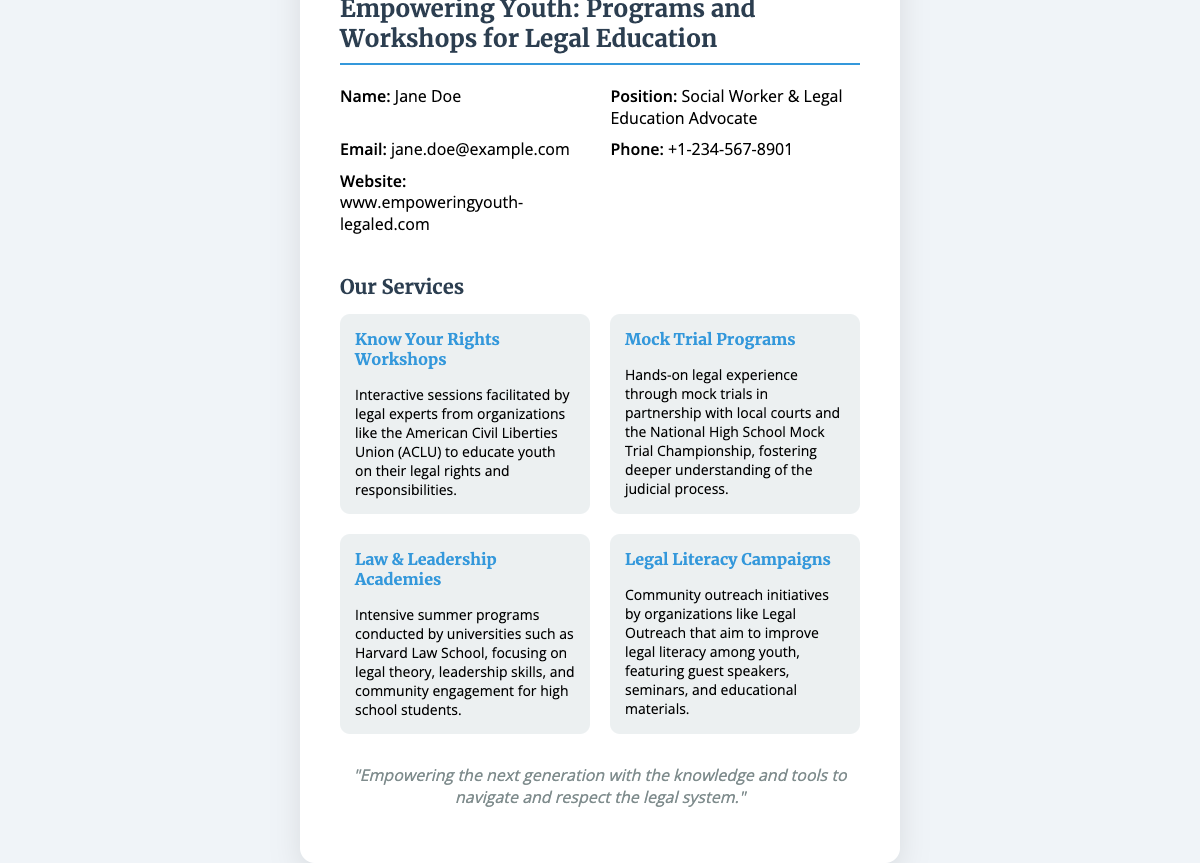what is the name of the advocate? The name of the advocate is provided in the contact information section of the document.
Answer: Jane Doe what is the phone number listed? The phone number is specified in the contact section of the document as the primary means of communication.
Answer: +1-234-567-8901 which organization partners for the Know Your Rights Workshops? The organization involved in the workshops is mentioned in the description of the service.
Answer: American Civil Liberties Union (ACLU) what is the mission statement? The mission statement encapsulates the purpose of the organization and is found at the bottom of the card.
Answer: "Empowering the next generation with the knowledge and tools to navigate and respect the legal system." how many services are listed on the card? The document details the number of services available as part of the programs offered.
Answer: Four what type of program is offered in partnership with local courts? This program type is highlighted along with its unique characteristics in the services section.
Answer: Mock Trial Programs what educational institutions are mentioned for the Law & Leadership Academies? The document gives specific examples of universities engaged in this program.
Answer: Harvard Law School what is the overall focus of the Legal Literacy Campaigns? The overarching goal of this campaign is outlined in the service description.
Answer: Improve legal literacy among youth 